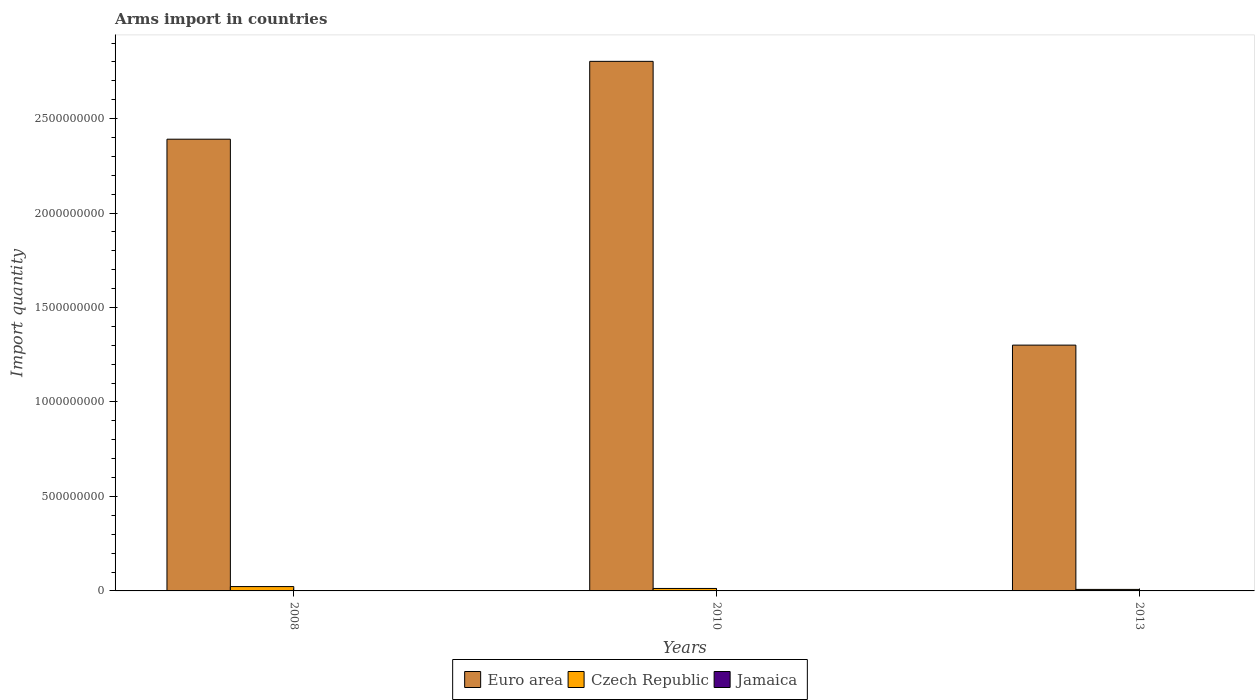How many different coloured bars are there?
Make the answer very short. 3. How many groups of bars are there?
Your response must be concise. 3. Are the number of bars per tick equal to the number of legend labels?
Ensure brevity in your answer.  Yes. How many bars are there on the 3rd tick from the left?
Ensure brevity in your answer.  3. In how many cases, is the number of bars for a given year not equal to the number of legend labels?
Provide a succinct answer. 0. What is the total arms import in Jamaica in 2010?
Offer a terse response. 1.00e+06. Across all years, what is the maximum total arms import in Czech Republic?
Your answer should be compact. 2.30e+07. In which year was the total arms import in Jamaica maximum?
Keep it short and to the point. 2008. What is the total total arms import in Euro area in the graph?
Your answer should be compact. 6.50e+09. What is the difference between the total arms import in Jamaica in 2008 and that in 2013?
Ensure brevity in your answer.  1.00e+06. What is the difference between the total arms import in Czech Republic in 2008 and the total arms import in Euro area in 2013?
Offer a terse response. -1.28e+09. What is the average total arms import in Euro area per year?
Provide a short and direct response. 2.16e+09. In the year 2013, what is the difference between the total arms import in Euro area and total arms import in Czech Republic?
Your response must be concise. 1.29e+09. What is the ratio of the total arms import in Czech Republic in 2010 to that in 2013?
Provide a short and direct response. 1.62. Is the difference between the total arms import in Euro area in 2010 and 2013 greater than the difference between the total arms import in Czech Republic in 2010 and 2013?
Give a very brief answer. Yes. What is the difference between the highest and the lowest total arms import in Euro area?
Provide a short and direct response. 1.50e+09. In how many years, is the total arms import in Czech Republic greater than the average total arms import in Czech Republic taken over all years?
Keep it short and to the point. 1. What does the 3rd bar from the left in 2008 represents?
Keep it short and to the point. Jamaica. What does the 1st bar from the right in 2008 represents?
Your answer should be very brief. Jamaica. Is it the case that in every year, the sum of the total arms import in Euro area and total arms import in Jamaica is greater than the total arms import in Czech Republic?
Your response must be concise. Yes. How many years are there in the graph?
Keep it short and to the point. 3. What is the difference between two consecutive major ticks on the Y-axis?
Your response must be concise. 5.00e+08. Does the graph contain any zero values?
Your answer should be compact. No. How many legend labels are there?
Offer a very short reply. 3. How are the legend labels stacked?
Your response must be concise. Horizontal. What is the title of the graph?
Offer a very short reply. Arms import in countries. What is the label or title of the X-axis?
Provide a succinct answer. Years. What is the label or title of the Y-axis?
Your answer should be compact. Import quantity. What is the Import quantity of Euro area in 2008?
Your answer should be compact. 2.39e+09. What is the Import quantity in Czech Republic in 2008?
Offer a very short reply. 2.30e+07. What is the Import quantity of Jamaica in 2008?
Ensure brevity in your answer.  2.00e+06. What is the Import quantity of Euro area in 2010?
Provide a short and direct response. 2.80e+09. What is the Import quantity of Czech Republic in 2010?
Offer a very short reply. 1.30e+07. What is the Import quantity in Jamaica in 2010?
Your response must be concise. 1.00e+06. What is the Import quantity in Euro area in 2013?
Make the answer very short. 1.30e+09. Across all years, what is the maximum Import quantity in Euro area?
Offer a very short reply. 2.80e+09. Across all years, what is the maximum Import quantity in Czech Republic?
Give a very brief answer. 2.30e+07. Across all years, what is the maximum Import quantity of Jamaica?
Make the answer very short. 2.00e+06. Across all years, what is the minimum Import quantity in Euro area?
Your answer should be very brief. 1.30e+09. Across all years, what is the minimum Import quantity of Jamaica?
Make the answer very short. 1.00e+06. What is the total Import quantity of Euro area in the graph?
Offer a terse response. 6.50e+09. What is the total Import quantity in Czech Republic in the graph?
Provide a succinct answer. 4.40e+07. What is the total Import quantity in Jamaica in the graph?
Keep it short and to the point. 4.00e+06. What is the difference between the Import quantity in Euro area in 2008 and that in 2010?
Your response must be concise. -4.12e+08. What is the difference between the Import quantity of Jamaica in 2008 and that in 2010?
Make the answer very short. 1.00e+06. What is the difference between the Import quantity in Euro area in 2008 and that in 2013?
Your response must be concise. 1.09e+09. What is the difference between the Import quantity in Czech Republic in 2008 and that in 2013?
Your answer should be compact. 1.50e+07. What is the difference between the Import quantity of Jamaica in 2008 and that in 2013?
Keep it short and to the point. 1.00e+06. What is the difference between the Import quantity of Euro area in 2010 and that in 2013?
Your response must be concise. 1.50e+09. What is the difference between the Import quantity in Euro area in 2008 and the Import quantity in Czech Republic in 2010?
Provide a short and direct response. 2.38e+09. What is the difference between the Import quantity in Euro area in 2008 and the Import quantity in Jamaica in 2010?
Your answer should be compact. 2.39e+09. What is the difference between the Import quantity in Czech Republic in 2008 and the Import quantity in Jamaica in 2010?
Ensure brevity in your answer.  2.20e+07. What is the difference between the Import quantity of Euro area in 2008 and the Import quantity of Czech Republic in 2013?
Provide a short and direct response. 2.38e+09. What is the difference between the Import quantity of Euro area in 2008 and the Import quantity of Jamaica in 2013?
Provide a succinct answer. 2.39e+09. What is the difference between the Import quantity of Czech Republic in 2008 and the Import quantity of Jamaica in 2013?
Your response must be concise. 2.20e+07. What is the difference between the Import quantity in Euro area in 2010 and the Import quantity in Czech Republic in 2013?
Your answer should be compact. 2.80e+09. What is the difference between the Import quantity of Euro area in 2010 and the Import quantity of Jamaica in 2013?
Ensure brevity in your answer.  2.80e+09. What is the average Import quantity in Euro area per year?
Offer a terse response. 2.16e+09. What is the average Import quantity of Czech Republic per year?
Your response must be concise. 1.47e+07. What is the average Import quantity in Jamaica per year?
Ensure brevity in your answer.  1.33e+06. In the year 2008, what is the difference between the Import quantity in Euro area and Import quantity in Czech Republic?
Give a very brief answer. 2.37e+09. In the year 2008, what is the difference between the Import quantity of Euro area and Import quantity of Jamaica?
Make the answer very short. 2.39e+09. In the year 2008, what is the difference between the Import quantity in Czech Republic and Import quantity in Jamaica?
Keep it short and to the point. 2.10e+07. In the year 2010, what is the difference between the Import quantity of Euro area and Import quantity of Czech Republic?
Offer a terse response. 2.79e+09. In the year 2010, what is the difference between the Import quantity in Euro area and Import quantity in Jamaica?
Your answer should be compact. 2.80e+09. In the year 2013, what is the difference between the Import quantity in Euro area and Import quantity in Czech Republic?
Your response must be concise. 1.29e+09. In the year 2013, what is the difference between the Import quantity in Euro area and Import quantity in Jamaica?
Offer a terse response. 1.30e+09. What is the ratio of the Import quantity of Euro area in 2008 to that in 2010?
Your answer should be compact. 0.85. What is the ratio of the Import quantity in Czech Republic in 2008 to that in 2010?
Ensure brevity in your answer.  1.77. What is the ratio of the Import quantity of Euro area in 2008 to that in 2013?
Your answer should be compact. 1.84. What is the ratio of the Import quantity in Czech Republic in 2008 to that in 2013?
Keep it short and to the point. 2.88. What is the ratio of the Import quantity in Jamaica in 2008 to that in 2013?
Provide a short and direct response. 2. What is the ratio of the Import quantity in Euro area in 2010 to that in 2013?
Offer a very short reply. 2.15. What is the ratio of the Import quantity in Czech Republic in 2010 to that in 2013?
Offer a terse response. 1.62. What is the ratio of the Import quantity of Jamaica in 2010 to that in 2013?
Provide a succinct answer. 1. What is the difference between the highest and the second highest Import quantity of Euro area?
Ensure brevity in your answer.  4.12e+08. What is the difference between the highest and the second highest Import quantity in Czech Republic?
Offer a very short reply. 1.00e+07. What is the difference between the highest and the second highest Import quantity in Jamaica?
Offer a terse response. 1.00e+06. What is the difference between the highest and the lowest Import quantity in Euro area?
Make the answer very short. 1.50e+09. What is the difference between the highest and the lowest Import quantity of Czech Republic?
Provide a succinct answer. 1.50e+07. What is the difference between the highest and the lowest Import quantity of Jamaica?
Your answer should be compact. 1.00e+06. 